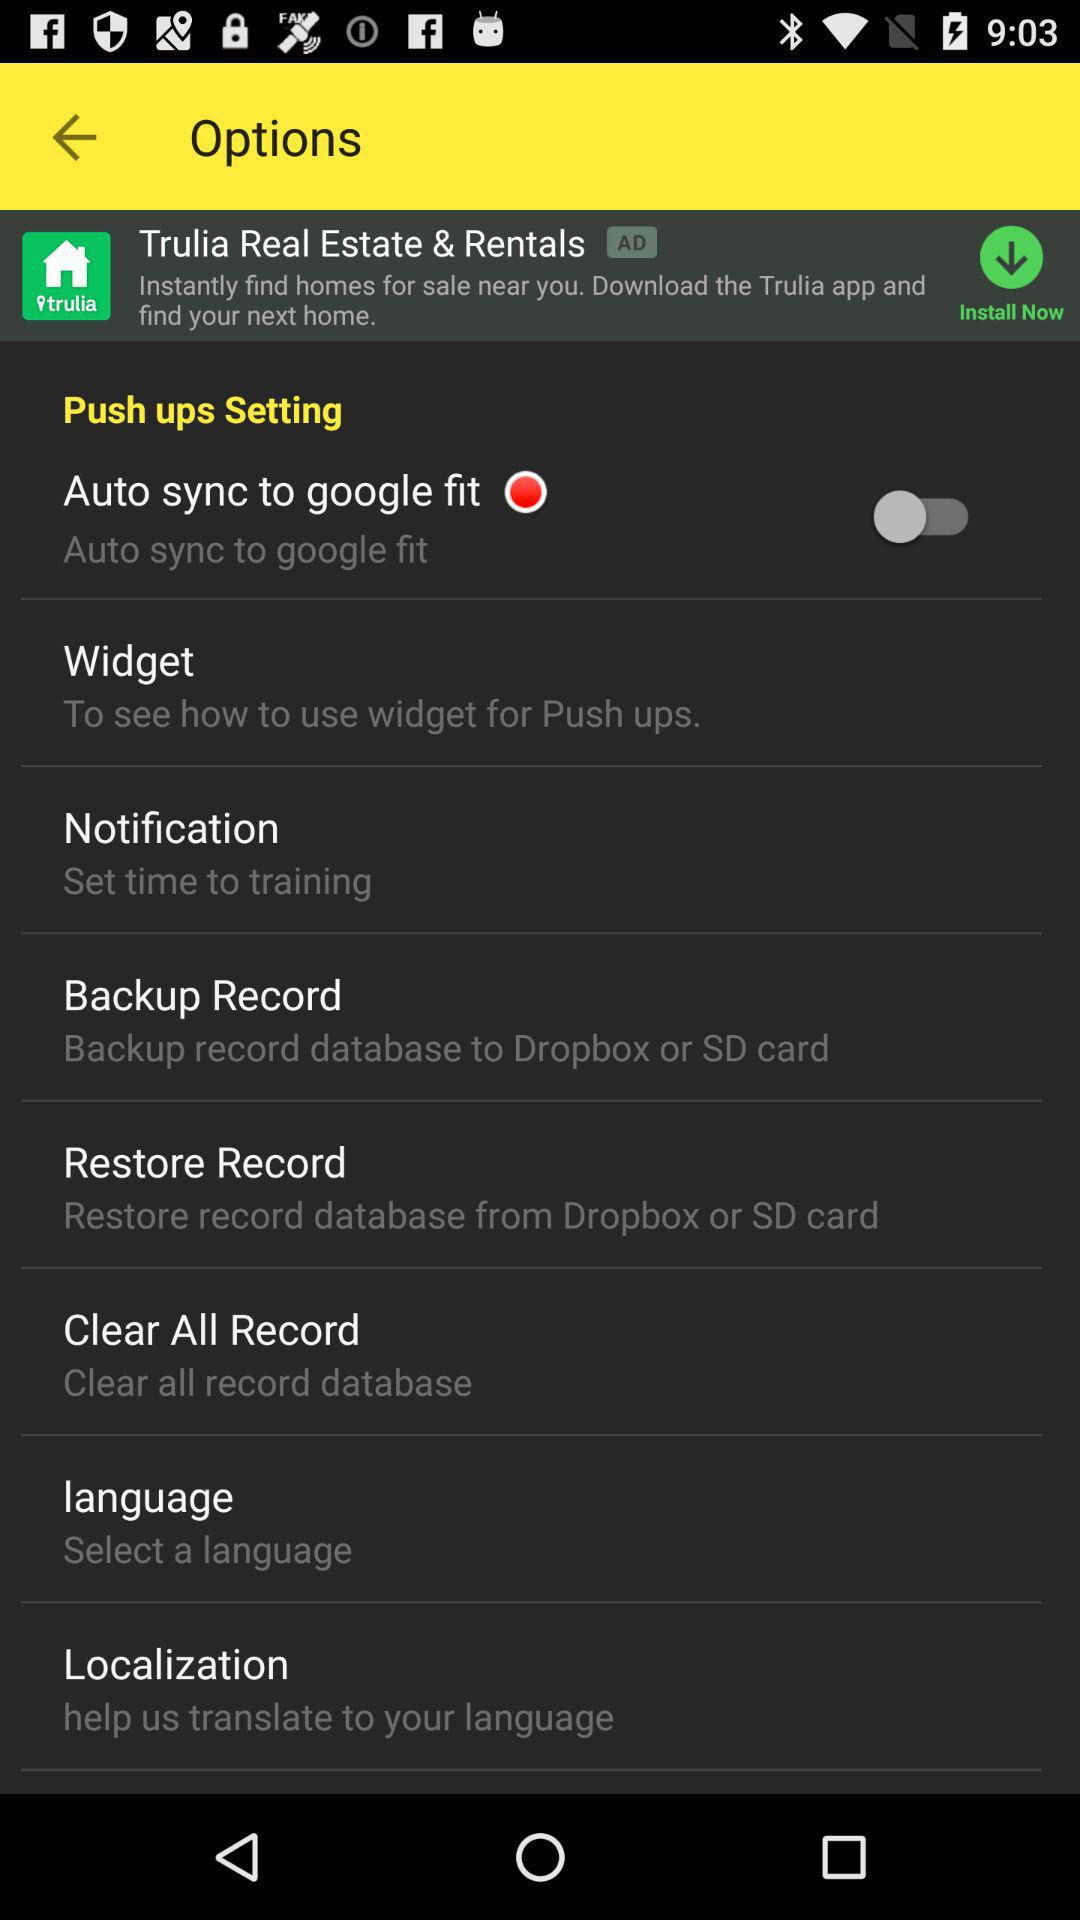What is the status of "Auto sync to google fit"? The status is "off". 